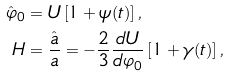<formula> <loc_0><loc_0><loc_500><loc_500>\hat { \varphi } _ { 0 } & = U \left [ 1 + \psi ( t ) \right ] , \\ H & = \frac { \hat { a } } { a } = - \frac { 2 } { 3 } \frac { d U } { d \varphi _ { 0 } } \left [ 1 + \gamma ( t ) \right ] ,</formula> 